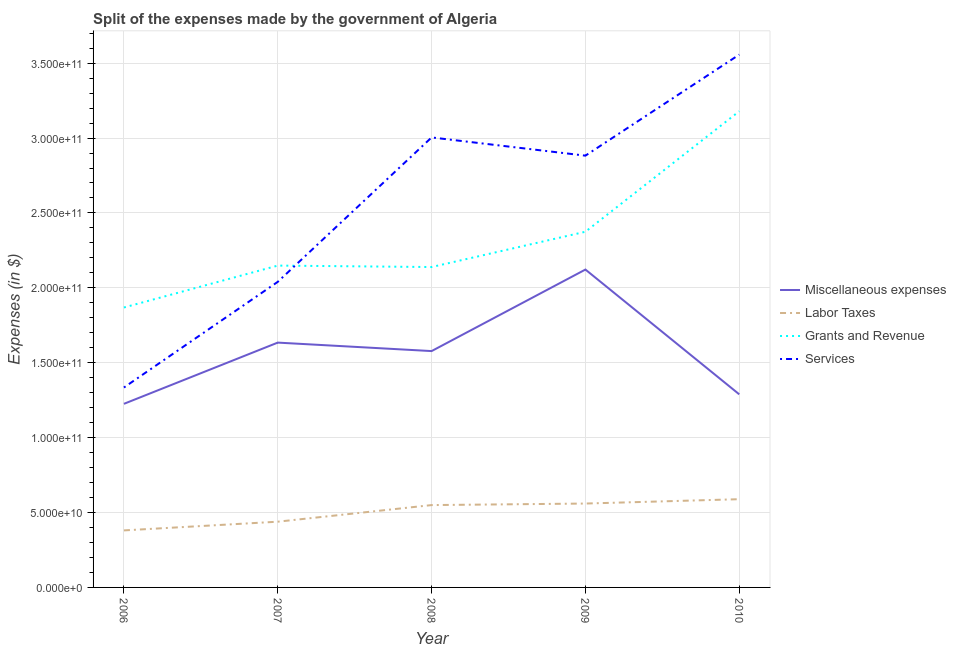Does the line corresponding to amount spent on services intersect with the line corresponding to amount spent on labor taxes?
Your answer should be compact. No. Is the number of lines equal to the number of legend labels?
Provide a succinct answer. Yes. What is the amount spent on grants and revenue in 2008?
Your response must be concise. 2.14e+11. Across all years, what is the maximum amount spent on grants and revenue?
Your answer should be compact. 3.18e+11. Across all years, what is the minimum amount spent on miscellaneous expenses?
Keep it short and to the point. 1.23e+11. In which year was the amount spent on miscellaneous expenses maximum?
Your answer should be compact. 2009. In which year was the amount spent on miscellaneous expenses minimum?
Your response must be concise. 2006. What is the total amount spent on grants and revenue in the graph?
Your answer should be compact. 1.17e+12. What is the difference between the amount spent on grants and revenue in 2007 and that in 2009?
Ensure brevity in your answer.  -2.26e+1. What is the difference between the amount spent on miscellaneous expenses in 2008 and the amount spent on grants and revenue in 2010?
Your answer should be compact. -1.60e+11. What is the average amount spent on services per year?
Keep it short and to the point. 2.56e+11. In the year 2010, what is the difference between the amount spent on grants and revenue and amount spent on miscellaneous expenses?
Your answer should be compact. 1.89e+11. What is the ratio of the amount spent on miscellaneous expenses in 2009 to that in 2010?
Offer a very short reply. 1.65. Is the amount spent on labor taxes in 2009 less than that in 2010?
Give a very brief answer. Yes. What is the difference between the highest and the second highest amount spent on labor taxes?
Your answer should be compact. 2.90e+09. What is the difference between the highest and the lowest amount spent on miscellaneous expenses?
Give a very brief answer. 8.96e+1. Is the sum of the amount spent on miscellaneous expenses in 2008 and 2009 greater than the maximum amount spent on services across all years?
Provide a short and direct response. Yes. Is it the case that in every year, the sum of the amount spent on grants and revenue and amount spent on services is greater than the sum of amount spent on labor taxes and amount spent on miscellaneous expenses?
Offer a terse response. No. Is it the case that in every year, the sum of the amount spent on miscellaneous expenses and amount spent on labor taxes is greater than the amount spent on grants and revenue?
Offer a very short reply. No. Is the amount spent on grants and revenue strictly less than the amount spent on miscellaneous expenses over the years?
Give a very brief answer. No. How many years are there in the graph?
Your answer should be very brief. 5. What is the difference between two consecutive major ticks on the Y-axis?
Provide a succinct answer. 5.00e+1. Are the values on the major ticks of Y-axis written in scientific E-notation?
Make the answer very short. Yes. Does the graph contain any zero values?
Ensure brevity in your answer.  No. Where does the legend appear in the graph?
Your answer should be compact. Center right. What is the title of the graph?
Give a very brief answer. Split of the expenses made by the government of Algeria. What is the label or title of the Y-axis?
Your answer should be compact. Expenses (in $). What is the Expenses (in $) of Miscellaneous expenses in 2006?
Your answer should be very brief. 1.23e+11. What is the Expenses (in $) of Labor Taxes in 2006?
Offer a terse response. 3.81e+1. What is the Expenses (in $) in Grants and Revenue in 2006?
Ensure brevity in your answer.  1.87e+11. What is the Expenses (in $) of Services in 2006?
Your response must be concise. 1.33e+11. What is the Expenses (in $) of Miscellaneous expenses in 2007?
Make the answer very short. 1.63e+11. What is the Expenses (in $) of Labor Taxes in 2007?
Keep it short and to the point. 4.39e+1. What is the Expenses (in $) of Grants and Revenue in 2007?
Provide a short and direct response. 2.15e+11. What is the Expenses (in $) of Services in 2007?
Provide a succinct answer. 2.04e+11. What is the Expenses (in $) of Miscellaneous expenses in 2008?
Offer a very short reply. 1.58e+11. What is the Expenses (in $) of Labor Taxes in 2008?
Offer a terse response. 5.50e+1. What is the Expenses (in $) in Grants and Revenue in 2008?
Offer a very short reply. 2.14e+11. What is the Expenses (in $) of Services in 2008?
Give a very brief answer. 3.00e+11. What is the Expenses (in $) in Miscellaneous expenses in 2009?
Your answer should be compact. 2.12e+11. What is the Expenses (in $) in Labor Taxes in 2009?
Offer a terse response. 5.60e+1. What is the Expenses (in $) in Grants and Revenue in 2009?
Ensure brevity in your answer.  2.37e+11. What is the Expenses (in $) in Services in 2009?
Offer a very short reply. 2.88e+11. What is the Expenses (in $) in Miscellaneous expenses in 2010?
Provide a succinct answer. 1.29e+11. What is the Expenses (in $) of Labor Taxes in 2010?
Make the answer very short. 5.89e+1. What is the Expenses (in $) of Grants and Revenue in 2010?
Give a very brief answer. 3.18e+11. What is the Expenses (in $) in Services in 2010?
Ensure brevity in your answer.  3.56e+11. Across all years, what is the maximum Expenses (in $) in Miscellaneous expenses?
Ensure brevity in your answer.  2.12e+11. Across all years, what is the maximum Expenses (in $) in Labor Taxes?
Your response must be concise. 5.89e+1. Across all years, what is the maximum Expenses (in $) of Grants and Revenue?
Make the answer very short. 3.18e+11. Across all years, what is the maximum Expenses (in $) in Services?
Your answer should be very brief. 3.56e+11. Across all years, what is the minimum Expenses (in $) in Miscellaneous expenses?
Offer a terse response. 1.23e+11. Across all years, what is the minimum Expenses (in $) of Labor Taxes?
Provide a short and direct response. 3.81e+1. Across all years, what is the minimum Expenses (in $) in Grants and Revenue?
Offer a very short reply. 1.87e+11. Across all years, what is the minimum Expenses (in $) of Services?
Offer a terse response. 1.33e+11. What is the total Expenses (in $) of Miscellaneous expenses in the graph?
Give a very brief answer. 7.85e+11. What is the total Expenses (in $) of Labor Taxes in the graph?
Ensure brevity in your answer.  2.52e+11. What is the total Expenses (in $) of Grants and Revenue in the graph?
Keep it short and to the point. 1.17e+12. What is the total Expenses (in $) in Services in the graph?
Provide a succinct answer. 1.28e+12. What is the difference between the Expenses (in $) in Miscellaneous expenses in 2006 and that in 2007?
Provide a short and direct response. -4.09e+1. What is the difference between the Expenses (in $) in Labor Taxes in 2006 and that in 2007?
Make the answer very short. -5.81e+09. What is the difference between the Expenses (in $) in Grants and Revenue in 2006 and that in 2007?
Make the answer very short. -2.80e+1. What is the difference between the Expenses (in $) in Services in 2006 and that in 2007?
Provide a short and direct response. -7.05e+1. What is the difference between the Expenses (in $) in Miscellaneous expenses in 2006 and that in 2008?
Give a very brief answer. -3.52e+1. What is the difference between the Expenses (in $) of Labor Taxes in 2006 and that in 2008?
Keep it short and to the point. -1.69e+1. What is the difference between the Expenses (in $) in Grants and Revenue in 2006 and that in 2008?
Your answer should be very brief. -2.70e+1. What is the difference between the Expenses (in $) in Services in 2006 and that in 2008?
Your answer should be compact. -1.67e+11. What is the difference between the Expenses (in $) in Miscellaneous expenses in 2006 and that in 2009?
Give a very brief answer. -8.96e+1. What is the difference between the Expenses (in $) in Labor Taxes in 2006 and that in 2009?
Provide a short and direct response. -1.79e+1. What is the difference between the Expenses (in $) of Grants and Revenue in 2006 and that in 2009?
Keep it short and to the point. -5.06e+1. What is the difference between the Expenses (in $) in Services in 2006 and that in 2009?
Make the answer very short. -1.55e+11. What is the difference between the Expenses (in $) of Miscellaneous expenses in 2006 and that in 2010?
Provide a short and direct response. -6.34e+09. What is the difference between the Expenses (in $) in Labor Taxes in 2006 and that in 2010?
Give a very brief answer. -2.08e+1. What is the difference between the Expenses (in $) of Grants and Revenue in 2006 and that in 2010?
Give a very brief answer. -1.31e+11. What is the difference between the Expenses (in $) in Services in 2006 and that in 2010?
Your answer should be very brief. -2.22e+11. What is the difference between the Expenses (in $) of Miscellaneous expenses in 2007 and that in 2008?
Keep it short and to the point. 5.66e+09. What is the difference between the Expenses (in $) in Labor Taxes in 2007 and that in 2008?
Your answer should be very brief. -1.11e+1. What is the difference between the Expenses (in $) in Grants and Revenue in 2007 and that in 2008?
Give a very brief answer. 9.60e+08. What is the difference between the Expenses (in $) of Services in 2007 and that in 2008?
Give a very brief answer. -9.64e+1. What is the difference between the Expenses (in $) of Miscellaneous expenses in 2007 and that in 2009?
Offer a very short reply. -4.88e+1. What is the difference between the Expenses (in $) of Labor Taxes in 2007 and that in 2009?
Keep it short and to the point. -1.21e+1. What is the difference between the Expenses (in $) in Grants and Revenue in 2007 and that in 2009?
Provide a short and direct response. -2.26e+1. What is the difference between the Expenses (in $) in Services in 2007 and that in 2009?
Provide a short and direct response. -8.43e+1. What is the difference between the Expenses (in $) of Miscellaneous expenses in 2007 and that in 2010?
Your response must be concise. 3.45e+1. What is the difference between the Expenses (in $) of Labor Taxes in 2007 and that in 2010?
Make the answer very short. -1.50e+1. What is the difference between the Expenses (in $) in Grants and Revenue in 2007 and that in 2010?
Make the answer very short. -1.03e+11. What is the difference between the Expenses (in $) in Services in 2007 and that in 2010?
Your answer should be very brief. -1.52e+11. What is the difference between the Expenses (in $) in Miscellaneous expenses in 2008 and that in 2009?
Your answer should be compact. -5.44e+1. What is the difference between the Expenses (in $) of Labor Taxes in 2008 and that in 2009?
Give a very brief answer. -1.03e+09. What is the difference between the Expenses (in $) in Grants and Revenue in 2008 and that in 2009?
Ensure brevity in your answer.  -2.36e+1. What is the difference between the Expenses (in $) of Services in 2008 and that in 2009?
Offer a very short reply. 1.22e+1. What is the difference between the Expenses (in $) in Miscellaneous expenses in 2008 and that in 2010?
Your answer should be compact. 2.89e+1. What is the difference between the Expenses (in $) in Labor Taxes in 2008 and that in 2010?
Give a very brief answer. -3.93e+09. What is the difference between the Expenses (in $) of Grants and Revenue in 2008 and that in 2010?
Provide a short and direct response. -1.04e+11. What is the difference between the Expenses (in $) of Services in 2008 and that in 2010?
Give a very brief answer. -5.53e+1. What is the difference between the Expenses (in $) of Miscellaneous expenses in 2009 and that in 2010?
Your response must be concise. 8.33e+1. What is the difference between the Expenses (in $) of Labor Taxes in 2009 and that in 2010?
Provide a succinct answer. -2.90e+09. What is the difference between the Expenses (in $) of Grants and Revenue in 2009 and that in 2010?
Your answer should be very brief. -8.04e+1. What is the difference between the Expenses (in $) in Services in 2009 and that in 2010?
Keep it short and to the point. -6.74e+1. What is the difference between the Expenses (in $) in Miscellaneous expenses in 2006 and the Expenses (in $) in Labor Taxes in 2007?
Provide a succinct answer. 7.87e+1. What is the difference between the Expenses (in $) of Miscellaneous expenses in 2006 and the Expenses (in $) of Grants and Revenue in 2007?
Give a very brief answer. -9.23e+1. What is the difference between the Expenses (in $) in Miscellaneous expenses in 2006 and the Expenses (in $) in Services in 2007?
Your answer should be very brief. -8.14e+1. What is the difference between the Expenses (in $) of Labor Taxes in 2006 and the Expenses (in $) of Grants and Revenue in 2007?
Provide a succinct answer. -1.77e+11. What is the difference between the Expenses (in $) in Labor Taxes in 2006 and the Expenses (in $) in Services in 2007?
Ensure brevity in your answer.  -1.66e+11. What is the difference between the Expenses (in $) of Grants and Revenue in 2006 and the Expenses (in $) of Services in 2007?
Offer a very short reply. -1.71e+1. What is the difference between the Expenses (in $) in Miscellaneous expenses in 2006 and the Expenses (in $) in Labor Taxes in 2008?
Make the answer very short. 6.76e+1. What is the difference between the Expenses (in $) in Miscellaneous expenses in 2006 and the Expenses (in $) in Grants and Revenue in 2008?
Provide a succinct answer. -9.13e+1. What is the difference between the Expenses (in $) of Miscellaneous expenses in 2006 and the Expenses (in $) of Services in 2008?
Provide a succinct answer. -1.78e+11. What is the difference between the Expenses (in $) of Labor Taxes in 2006 and the Expenses (in $) of Grants and Revenue in 2008?
Ensure brevity in your answer.  -1.76e+11. What is the difference between the Expenses (in $) in Labor Taxes in 2006 and the Expenses (in $) in Services in 2008?
Provide a short and direct response. -2.62e+11. What is the difference between the Expenses (in $) in Grants and Revenue in 2006 and the Expenses (in $) in Services in 2008?
Ensure brevity in your answer.  -1.14e+11. What is the difference between the Expenses (in $) in Miscellaneous expenses in 2006 and the Expenses (in $) in Labor Taxes in 2009?
Keep it short and to the point. 6.66e+1. What is the difference between the Expenses (in $) in Miscellaneous expenses in 2006 and the Expenses (in $) in Grants and Revenue in 2009?
Give a very brief answer. -1.15e+11. What is the difference between the Expenses (in $) in Miscellaneous expenses in 2006 and the Expenses (in $) in Services in 2009?
Provide a short and direct response. -1.66e+11. What is the difference between the Expenses (in $) of Labor Taxes in 2006 and the Expenses (in $) of Grants and Revenue in 2009?
Keep it short and to the point. -1.99e+11. What is the difference between the Expenses (in $) of Labor Taxes in 2006 and the Expenses (in $) of Services in 2009?
Make the answer very short. -2.50e+11. What is the difference between the Expenses (in $) of Grants and Revenue in 2006 and the Expenses (in $) of Services in 2009?
Your answer should be very brief. -1.01e+11. What is the difference between the Expenses (in $) of Miscellaneous expenses in 2006 and the Expenses (in $) of Labor Taxes in 2010?
Give a very brief answer. 6.37e+1. What is the difference between the Expenses (in $) in Miscellaneous expenses in 2006 and the Expenses (in $) in Grants and Revenue in 2010?
Your answer should be compact. -1.95e+11. What is the difference between the Expenses (in $) in Miscellaneous expenses in 2006 and the Expenses (in $) in Services in 2010?
Keep it short and to the point. -2.33e+11. What is the difference between the Expenses (in $) of Labor Taxes in 2006 and the Expenses (in $) of Grants and Revenue in 2010?
Provide a short and direct response. -2.80e+11. What is the difference between the Expenses (in $) in Labor Taxes in 2006 and the Expenses (in $) in Services in 2010?
Offer a terse response. -3.18e+11. What is the difference between the Expenses (in $) in Grants and Revenue in 2006 and the Expenses (in $) in Services in 2010?
Offer a terse response. -1.69e+11. What is the difference between the Expenses (in $) of Miscellaneous expenses in 2007 and the Expenses (in $) of Labor Taxes in 2008?
Your answer should be compact. 1.08e+11. What is the difference between the Expenses (in $) in Miscellaneous expenses in 2007 and the Expenses (in $) in Grants and Revenue in 2008?
Provide a succinct answer. -5.04e+1. What is the difference between the Expenses (in $) of Miscellaneous expenses in 2007 and the Expenses (in $) of Services in 2008?
Your answer should be compact. -1.37e+11. What is the difference between the Expenses (in $) of Labor Taxes in 2007 and the Expenses (in $) of Grants and Revenue in 2008?
Your response must be concise. -1.70e+11. What is the difference between the Expenses (in $) in Labor Taxes in 2007 and the Expenses (in $) in Services in 2008?
Offer a very short reply. -2.57e+11. What is the difference between the Expenses (in $) of Grants and Revenue in 2007 and the Expenses (in $) of Services in 2008?
Your response must be concise. -8.56e+1. What is the difference between the Expenses (in $) in Miscellaneous expenses in 2007 and the Expenses (in $) in Labor Taxes in 2009?
Make the answer very short. 1.07e+11. What is the difference between the Expenses (in $) of Miscellaneous expenses in 2007 and the Expenses (in $) of Grants and Revenue in 2009?
Your answer should be compact. -7.40e+1. What is the difference between the Expenses (in $) of Miscellaneous expenses in 2007 and the Expenses (in $) of Services in 2009?
Keep it short and to the point. -1.25e+11. What is the difference between the Expenses (in $) of Labor Taxes in 2007 and the Expenses (in $) of Grants and Revenue in 2009?
Your answer should be compact. -1.94e+11. What is the difference between the Expenses (in $) in Labor Taxes in 2007 and the Expenses (in $) in Services in 2009?
Give a very brief answer. -2.44e+11. What is the difference between the Expenses (in $) of Grants and Revenue in 2007 and the Expenses (in $) of Services in 2009?
Give a very brief answer. -7.34e+1. What is the difference between the Expenses (in $) in Miscellaneous expenses in 2007 and the Expenses (in $) in Labor Taxes in 2010?
Offer a very short reply. 1.05e+11. What is the difference between the Expenses (in $) of Miscellaneous expenses in 2007 and the Expenses (in $) of Grants and Revenue in 2010?
Ensure brevity in your answer.  -1.54e+11. What is the difference between the Expenses (in $) of Miscellaneous expenses in 2007 and the Expenses (in $) of Services in 2010?
Offer a terse response. -1.92e+11. What is the difference between the Expenses (in $) of Labor Taxes in 2007 and the Expenses (in $) of Grants and Revenue in 2010?
Offer a very short reply. -2.74e+11. What is the difference between the Expenses (in $) of Labor Taxes in 2007 and the Expenses (in $) of Services in 2010?
Provide a short and direct response. -3.12e+11. What is the difference between the Expenses (in $) in Grants and Revenue in 2007 and the Expenses (in $) in Services in 2010?
Your answer should be compact. -1.41e+11. What is the difference between the Expenses (in $) in Miscellaneous expenses in 2008 and the Expenses (in $) in Labor Taxes in 2009?
Give a very brief answer. 1.02e+11. What is the difference between the Expenses (in $) in Miscellaneous expenses in 2008 and the Expenses (in $) in Grants and Revenue in 2009?
Your answer should be compact. -7.97e+1. What is the difference between the Expenses (in $) in Miscellaneous expenses in 2008 and the Expenses (in $) in Services in 2009?
Offer a very short reply. -1.30e+11. What is the difference between the Expenses (in $) of Labor Taxes in 2008 and the Expenses (in $) of Grants and Revenue in 2009?
Make the answer very short. -1.82e+11. What is the difference between the Expenses (in $) in Labor Taxes in 2008 and the Expenses (in $) in Services in 2009?
Your response must be concise. -2.33e+11. What is the difference between the Expenses (in $) of Grants and Revenue in 2008 and the Expenses (in $) of Services in 2009?
Offer a terse response. -7.44e+1. What is the difference between the Expenses (in $) in Miscellaneous expenses in 2008 and the Expenses (in $) in Labor Taxes in 2010?
Provide a succinct answer. 9.89e+1. What is the difference between the Expenses (in $) in Miscellaneous expenses in 2008 and the Expenses (in $) in Grants and Revenue in 2010?
Provide a succinct answer. -1.60e+11. What is the difference between the Expenses (in $) of Miscellaneous expenses in 2008 and the Expenses (in $) of Services in 2010?
Provide a short and direct response. -1.98e+11. What is the difference between the Expenses (in $) of Labor Taxes in 2008 and the Expenses (in $) of Grants and Revenue in 2010?
Provide a succinct answer. -2.63e+11. What is the difference between the Expenses (in $) in Labor Taxes in 2008 and the Expenses (in $) in Services in 2010?
Make the answer very short. -3.01e+11. What is the difference between the Expenses (in $) of Grants and Revenue in 2008 and the Expenses (in $) of Services in 2010?
Make the answer very short. -1.42e+11. What is the difference between the Expenses (in $) of Miscellaneous expenses in 2009 and the Expenses (in $) of Labor Taxes in 2010?
Your response must be concise. 1.53e+11. What is the difference between the Expenses (in $) in Miscellaneous expenses in 2009 and the Expenses (in $) in Grants and Revenue in 2010?
Your response must be concise. -1.06e+11. What is the difference between the Expenses (in $) of Miscellaneous expenses in 2009 and the Expenses (in $) of Services in 2010?
Provide a succinct answer. -1.43e+11. What is the difference between the Expenses (in $) of Labor Taxes in 2009 and the Expenses (in $) of Grants and Revenue in 2010?
Your answer should be very brief. -2.62e+11. What is the difference between the Expenses (in $) in Labor Taxes in 2009 and the Expenses (in $) in Services in 2010?
Offer a very short reply. -3.00e+11. What is the difference between the Expenses (in $) of Grants and Revenue in 2009 and the Expenses (in $) of Services in 2010?
Your answer should be very brief. -1.18e+11. What is the average Expenses (in $) of Miscellaneous expenses per year?
Your response must be concise. 1.57e+11. What is the average Expenses (in $) of Labor Taxes per year?
Ensure brevity in your answer.  5.04e+1. What is the average Expenses (in $) of Grants and Revenue per year?
Your answer should be compact. 2.34e+11. What is the average Expenses (in $) in Services per year?
Your answer should be compact. 2.56e+11. In the year 2006, what is the difference between the Expenses (in $) of Miscellaneous expenses and Expenses (in $) of Labor Taxes?
Your answer should be very brief. 8.45e+1. In the year 2006, what is the difference between the Expenses (in $) in Miscellaneous expenses and Expenses (in $) in Grants and Revenue?
Your answer should be compact. -6.43e+1. In the year 2006, what is the difference between the Expenses (in $) in Miscellaneous expenses and Expenses (in $) in Services?
Your answer should be very brief. -1.09e+1. In the year 2006, what is the difference between the Expenses (in $) of Labor Taxes and Expenses (in $) of Grants and Revenue?
Your answer should be very brief. -1.49e+11. In the year 2006, what is the difference between the Expenses (in $) of Labor Taxes and Expenses (in $) of Services?
Ensure brevity in your answer.  -9.54e+1. In the year 2006, what is the difference between the Expenses (in $) in Grants and Revenue and Expenses (in $) in Services?
Your answer should be compact. 5.34e+1. In the year 2007, what is the difference between the Expenses (in $) of Miscellaneous expenses and Expenses (in $) of Labor Taxes?
Your response must be concise. 1.20e+11. In the year 2007, what is the difference between the Expenses (in $) in Miscellaneous expenses and Expenses (in $) in Grants and Revenue?
Offer a very short reply. -5.14e+1. In the year 2007, what is the difference between the Expenses (in $) of Miscellaneous expenses and Expenses (in $) of Services?
Provide a succinct answer. -4.06e+1. In the year 2007, what is the difference between the Expenses (in $) in Labor Taxes and Expenses (in $) in Grants and Revenue?
Give a very brief answer. -1.71e+11. In the year 2007, what is the difference between the Expenses (in $) in Labor Taxes and Expenses (in $) in Services?
Your answer should be compact. -1.60e+11. In the year 2007, what is the difference between the Expenses (in $) in Grants and Revenue and Expenses (in $) in Services?
Offer a terse response. 1.08e+1. In the year 2008, what is the difference between the Expenses (in $) in Miscellaneous expenses and Expenses (in $) in Labor Taxes?
Your answer should be very brief. 1.03e+11. In the year 2008, what is the difference between the Expenses (in $) in Miscellaneous expenses and Expenses (in $) in Grants and Revenue?
Ensure brevity in your answer.  -5.61e+1. In the year 2008, what is the difference between the Expenses (in $) of Miscellaneous expenses and Expenses (in $) of Services?
Offer a terse response. -1.43e+11. In the year 2008, what is the difference between the Expenses (in $) of Labor Taxes and Expenses (in $) of Grants and Revenue?
Give a very brief answer. -1.59e+11. In the year 2008, what is the difference between the Expenses (in $) in Labor Taxes and Expenses (in $) in Services?
Ensure brevity in your answer.  -2.45e+11. In the year 2008, what is the difference between the Expenses (in $) of Grants and Revenue and Expenses (in $) of Services?
Your answer should be very brief. -8.65e+1. In the year 2009, what is the difference between the Expenses (in $) in Miscellaneous expenses and Expenses (in $) in Labor Taxes?
Your answer should be very brief. 1.56e+11. In the year 2009, what is the difference between the Expenses (in $) of Miscellaneous expenses and Expenses (in $) of Grants and Revenue?
Offer a terse response. -2.52e+1. In the year 2009, what is the difference between the Expenses (in $) in Miscellaneous expenses and Expenses (in $) in Services?
Offer a very short reply. -7.60e+1. In the year 2009, what is the difference between the Expenses (in $) of Labor Taxes and Expenses (in $) of Grants and Revenue?
Offer a very short reply. -1.81e+11. In the year 2009, what is the difference between the Expenses (in $) in Labor Taxes and Expenses (in $) in Services?
Provide a short and direct response. -2.32e+11. In the year 2009, what is the difference between the Expenses (in $) of Grants and Revenue and Expenses (in $) of Services?
Provide a succinct answer. -5.08e+1. In the year 2010, what is the difference between the Expenses (in $) of Miscellaneous expenses and Expenses (in $) of Labor Taxes?
Keep it short and to the point. 7.00e+1. In the year 2010, what is the difference between the Expenses (in $) in Miscellaneous expenses and Expenses (in $) in Grants and Revenue?
Offer a very short reply. -1.89e+11. In the year 2010, what is the difference between the Expenses (in $) of Miscellaneous expenses and Expenses (in $) of Services?
Your answer should be compact. -2.27e+11. In the year 2010, what is the difference between the Expenses (in $) of Labor Taxes and Expenses (in $) of Grants and Revenue?
Ensure brevity in your answer.  -2.59e+11. In the year 2010, what is the difference between the Expenses (in $) of Labor Taxes and Expenses (in $) of Services?
Keep it short and to the point. -2.97e+11. In the year 2010, what is the difference between the Expenses (in $) of Grants and Revenue and Expenses (in $) of Services?
Offer a terse response. -3.78e+1. What is the ratio of the Expenses (in $) in Miscellaneous expenses in 2006 to that in 2007?
Your answer should be very brief. 0.75. What is the ratio of the Expenses (in $) of Labor Taxes in 2006 to that in 2007?
Ensure brevity in your answer.  0.87. What is the ratio of the Expenses (in $) of Grants and Revenue in 2006 to that in 2007?
Provide a succinct answer. 0.87. What is the ratio of the Expenses (in $) of Services in 2006 to that in 2007?
Ensure brevity in your answer.  0.65. What is the ratio of the Expenses (in $) of Miscellaneous expenses in 2006 to that in 2008?
Your answer should be very brief. 0.78. What is the ratio of the Expenses (in $) of Labor Taxes in 2006 to that in 2008?
Your response must be concise. 0.69. What is the ratio of the Expenses (in $) of Grants and Revenue in 2006 to that in 2008?
Offer a very short reply. 0.87. What is the ratio of the Expenses (in $) in Services in 2006 to that in 2008?
Offer a very short reply. 0.44. What is the ratio of the Expenses (in $) of Miscellaneous expenses in 2006 to that in 2009?
Your response must be concise. 0.58. What is the ratio of the Expenses (in $) of Labor Taxes in 2006 to that in 2009?
Give a very brief answer. 0.68. What is the ratio of the Expenses (in $) in Grants and Revenue in 2006 to that in 2009?
Offer a very short reply. 0.79. What is the ratio of the Expenses (in $) of Services in 2006 to that in 2009?
Provide a short and direct response. 0.46. What is the ratio of the Expenses (in $) of Miscellaneous expenses in 2006 to that in 2010?
Give a very brief answer. 0.95. What is the ratio of the Expenses (in $) in Labor Taxes in 2006 to that in 2010?
Keep it short and to the point. 0.65. What is the ratio of the Expenses (in $) in Grants and Revenue in 2006 to that in 2010?
Provide a short and direct response. 0.59. What is the ratio of the Expenses (in $) of Services in 2006 to that in 2010?
Your answer should be very brief. 0.38. What is the ratio of the Expenses (in $) in Miscellaneous expenses in 2007 to that in 2008?
Offer a terse response. 1.04. What is the ratio of the Expenses (in $) in Labor Taxes in 2007 to that in 2008?
Your answer should be compact. 0.8. What is the ratio of the Expenses (in $) in Services in 2007 to that in 2008?
Offer a terse response. 0.68. What is the ratio of the Expenses (in $) of Miscellaneous expenses in 2007 to that in 2009?
Your answer should be very brief. 0.77. What is the ratio of the Expenses (in $) in Labor Taxes in 2007 to that in 2009?
Ensure brevity in your answer.  0.78. What is the ratio of the Expenses (in $) of Grants and Revenue in 2007 to that in 2009?
Your answer should be compact. 0.9. What is the ratio of the Expenses (in $) in Services in 2007 to that in 2009?
Provide a short and direct response. 0.71. What is the ratio of the Expenses (in $) of Miscellaneous expenses in 2007 to that in 2010?
Make the answer very short. 1.27. What is the ratio of the Expenses (in $) of Labor Taxes in 2007 to that in 2010?
Ensure brevity in your answer.  0.74. What is the ratio of the Expenses (in $) of Grants and Revenue in 2007 to that in 2010?
Give a very brief answer. 0.68. What is the ratio of the Expenses (in $) of Services in 2007 to that in 2010?
Provide a short and direct response. 0.57. What is the ratio of the Expenses (in $) in Miscellaneous expenses in 2008 to that in 2009?
Your response must be concise. 0.74. What is the ratio of the Expenses (in $) of Labor Taxes in 2008 to that in 2009?
Your response must be concise. 0.98. What is the ratio of the Expenses (in $) in Grants and Revenue in 2008 to that in 2009?
Ensure brevity in your answer.  0.9. What is the ratio of the Expenses (in $) in Services in 2008 to that in 2009?
Ensure brevity in your answer.  1.04. What is the ratio of the Expenses (in $) of Miscellaneous expenses in 2008 to that in 2010?
Offer a very short reply. 1.22. What is the ratio of the Expenses (in $) of Grants and Revenue in 2008 to that in 2010?
Your answer should be very brief. 0.67. What is the ratio of the Expenses (in $) in Services in 2008 to that in 2010?
Offer a terse response. 0.84. What is the ratio of the Expenses (in $) in Miscellaneous expenses in 2009 to that in 2010?
Provide a short and direct response. 1.65. What is the ratio of the Expenses (in $) of Labor Taxes in 2009 to that in 2010?
Keep it short and to the point. 0.95. What is the ratio of the Expenses (in $) of Grants and Revenue in 2009 to that in 2010?
Offer a very short reply. 0.75. What is the ratio of the Expenses (in $) of Services in 2009 to that in 2010?
Provide a succinct answer. 0.81. What is the difference between the highest and the second highest Expenses (in $) in Miscellaneous expenses?
Offer a terse response. 4.88e+1. What is the difference between the highest and the second highest Expenses (in $) in Labor Taxes?
Provide a succinct answer. 2.90e+09. What is the difference between the highest and the second highest Expenses (in $) of Grants and Revenue?
Provide a succinct answer. 8.04e+1. What is the difference between the highest and the second highest Expenses (in $) of Services?
Offer a very short reply. 5.53e+1. What is the difference between the highest and the lowest Expenses (in $) of Miscellaneous expenses?
Ensure brevity in your answer.  8.96e+1. What is the difference between the highest and the lowest Expenses (in $) in Labor Taxes?
Provide a succinct answer. 2.08e+1. What is the difference between the highest and the lowest Expenses (in $) of Grants and Revenue?
Keep it short and to the point. 1.31e+11. What is the difference between the highest and the lowest Expenses (in $) in Services?
Offer a very short reply. 2.22e+11. 